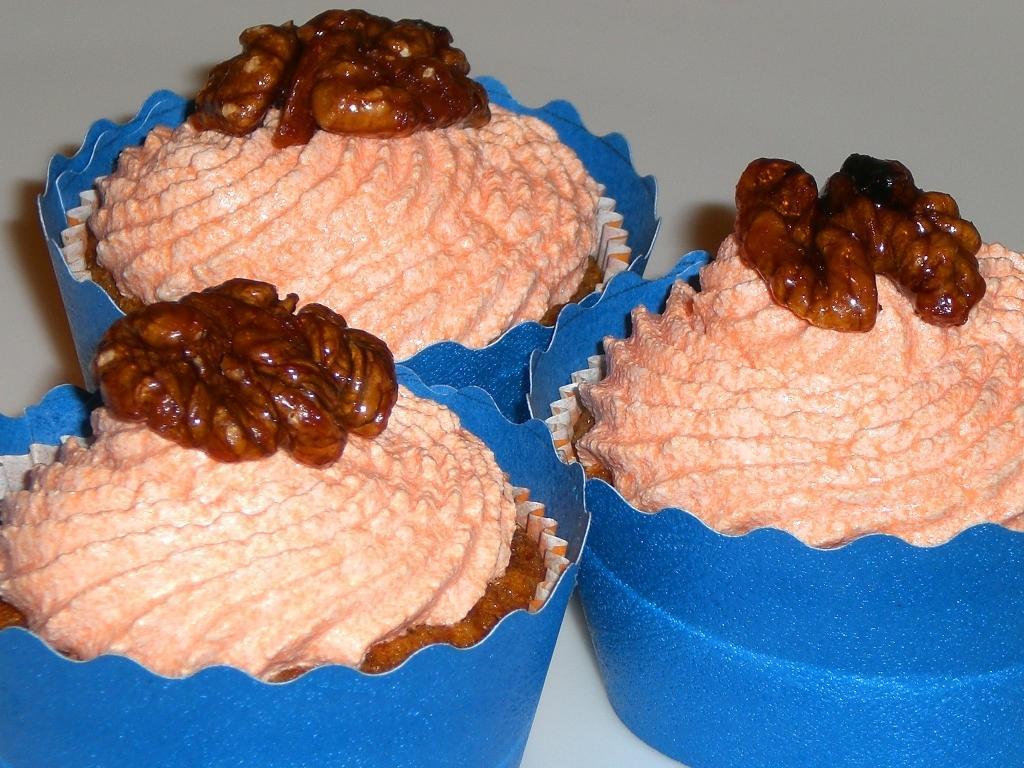Describe this image in one or two sentences. In the picture I can see three cupcakes. 